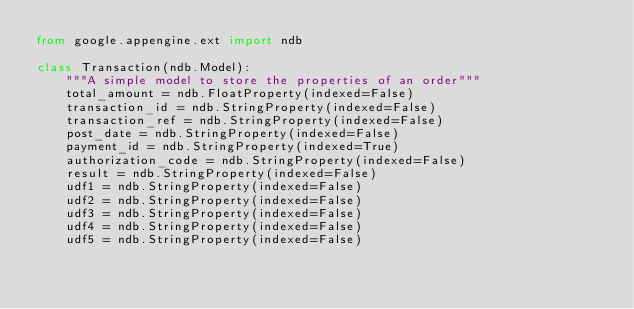Convert code to text. <code><loc_0><loc_0><loc_500><loc_500><_Python_>from google.appengine.ext import ndb

class Transaction(ndb.Model):
    """A simple model to store the properties of an order"""
    total_amount = ndb.FloatProperty(indexed=False)
    transaction_id = ndb.StringProperty(indexed=False)
    transaction_ref = ndb.StringProperty(indexed=False)
    post_date = ndb.StringProperty(indexed=False)
    payment_id = ndb.StringProperty(indexed=True)
    authorization_code = ndb.StringProperty(indexed=False)
    result = ndb.StringProperty(indexed=False)
    udf1 = ndb.StringProperty(indexed=False)
    udf2 = ndb.StringProperty(indexed=False)
    udf3 = ndb.StringProperty(indexed=False)
    udf4 = ndb.StringProperty(indexed=False)
    udf5 = ndb.StringProperty(indexed=False)</code> 